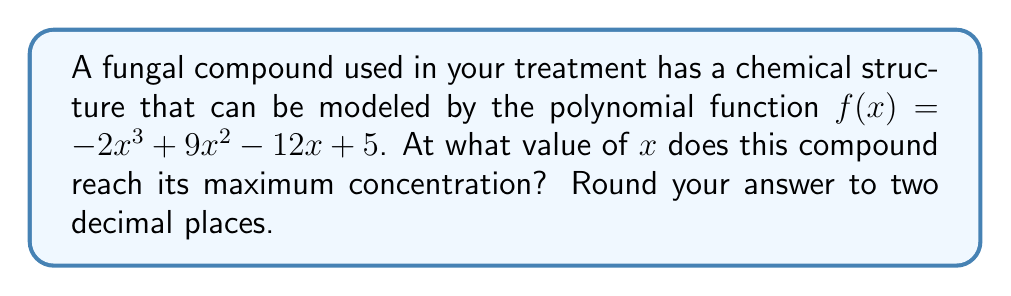Could you help me with this problem? To find the maximum concentration, we need to follow these steps:

1) The maximum point occurs where the derivative of the function is zero. Let's find the derivative:

   $f'(x) = -6x^2 + 18x - 12$

2) Set the derivative equal to zero:

   $-6x^2 + 18x - 12 = 0$

3) This is a quadratic equation. We can solve it using the quadratic formula:
   
   $x = \frac{-b \pm \sqrt{b^2 - 4ac}}{2a}$

   Where $a = -6$, $b = 18$, and $c = -12$

4) Substituting these values:

   $x = \frac{-18 \pm \sqrt{18^2 - 4(-6)(-12)}}{2(-6)}$

5) Simplify:

   $x = \frac{-18 \pm \sqrt{324 - 288}}{-12} = \frac{-18 \pm \sqrt{36}}{-12} = \frac{-18 \pm 6}{-12}$

6) This gives us two solutions:

   $x = \frac{-18 + 6}{-12} = 1$ or $x = \frac{-18 - 6}{-12} = 2$

7) To determine which of these gives the maximum (rather than minimum) point, we can check the second derivative:

   $f''(x) = -12x + 18$

8) At $x = 1$: $f''(1) = -12(1) + 18 = 6$ (positive, so this is a minimum)
   At $x = 2$: $f''(2) = -12(2) + 18 = -6$ (negative, so this is a maximum)

Therefore, the maximum concentration occurs at $x = 2$.
Answer: 2.00 